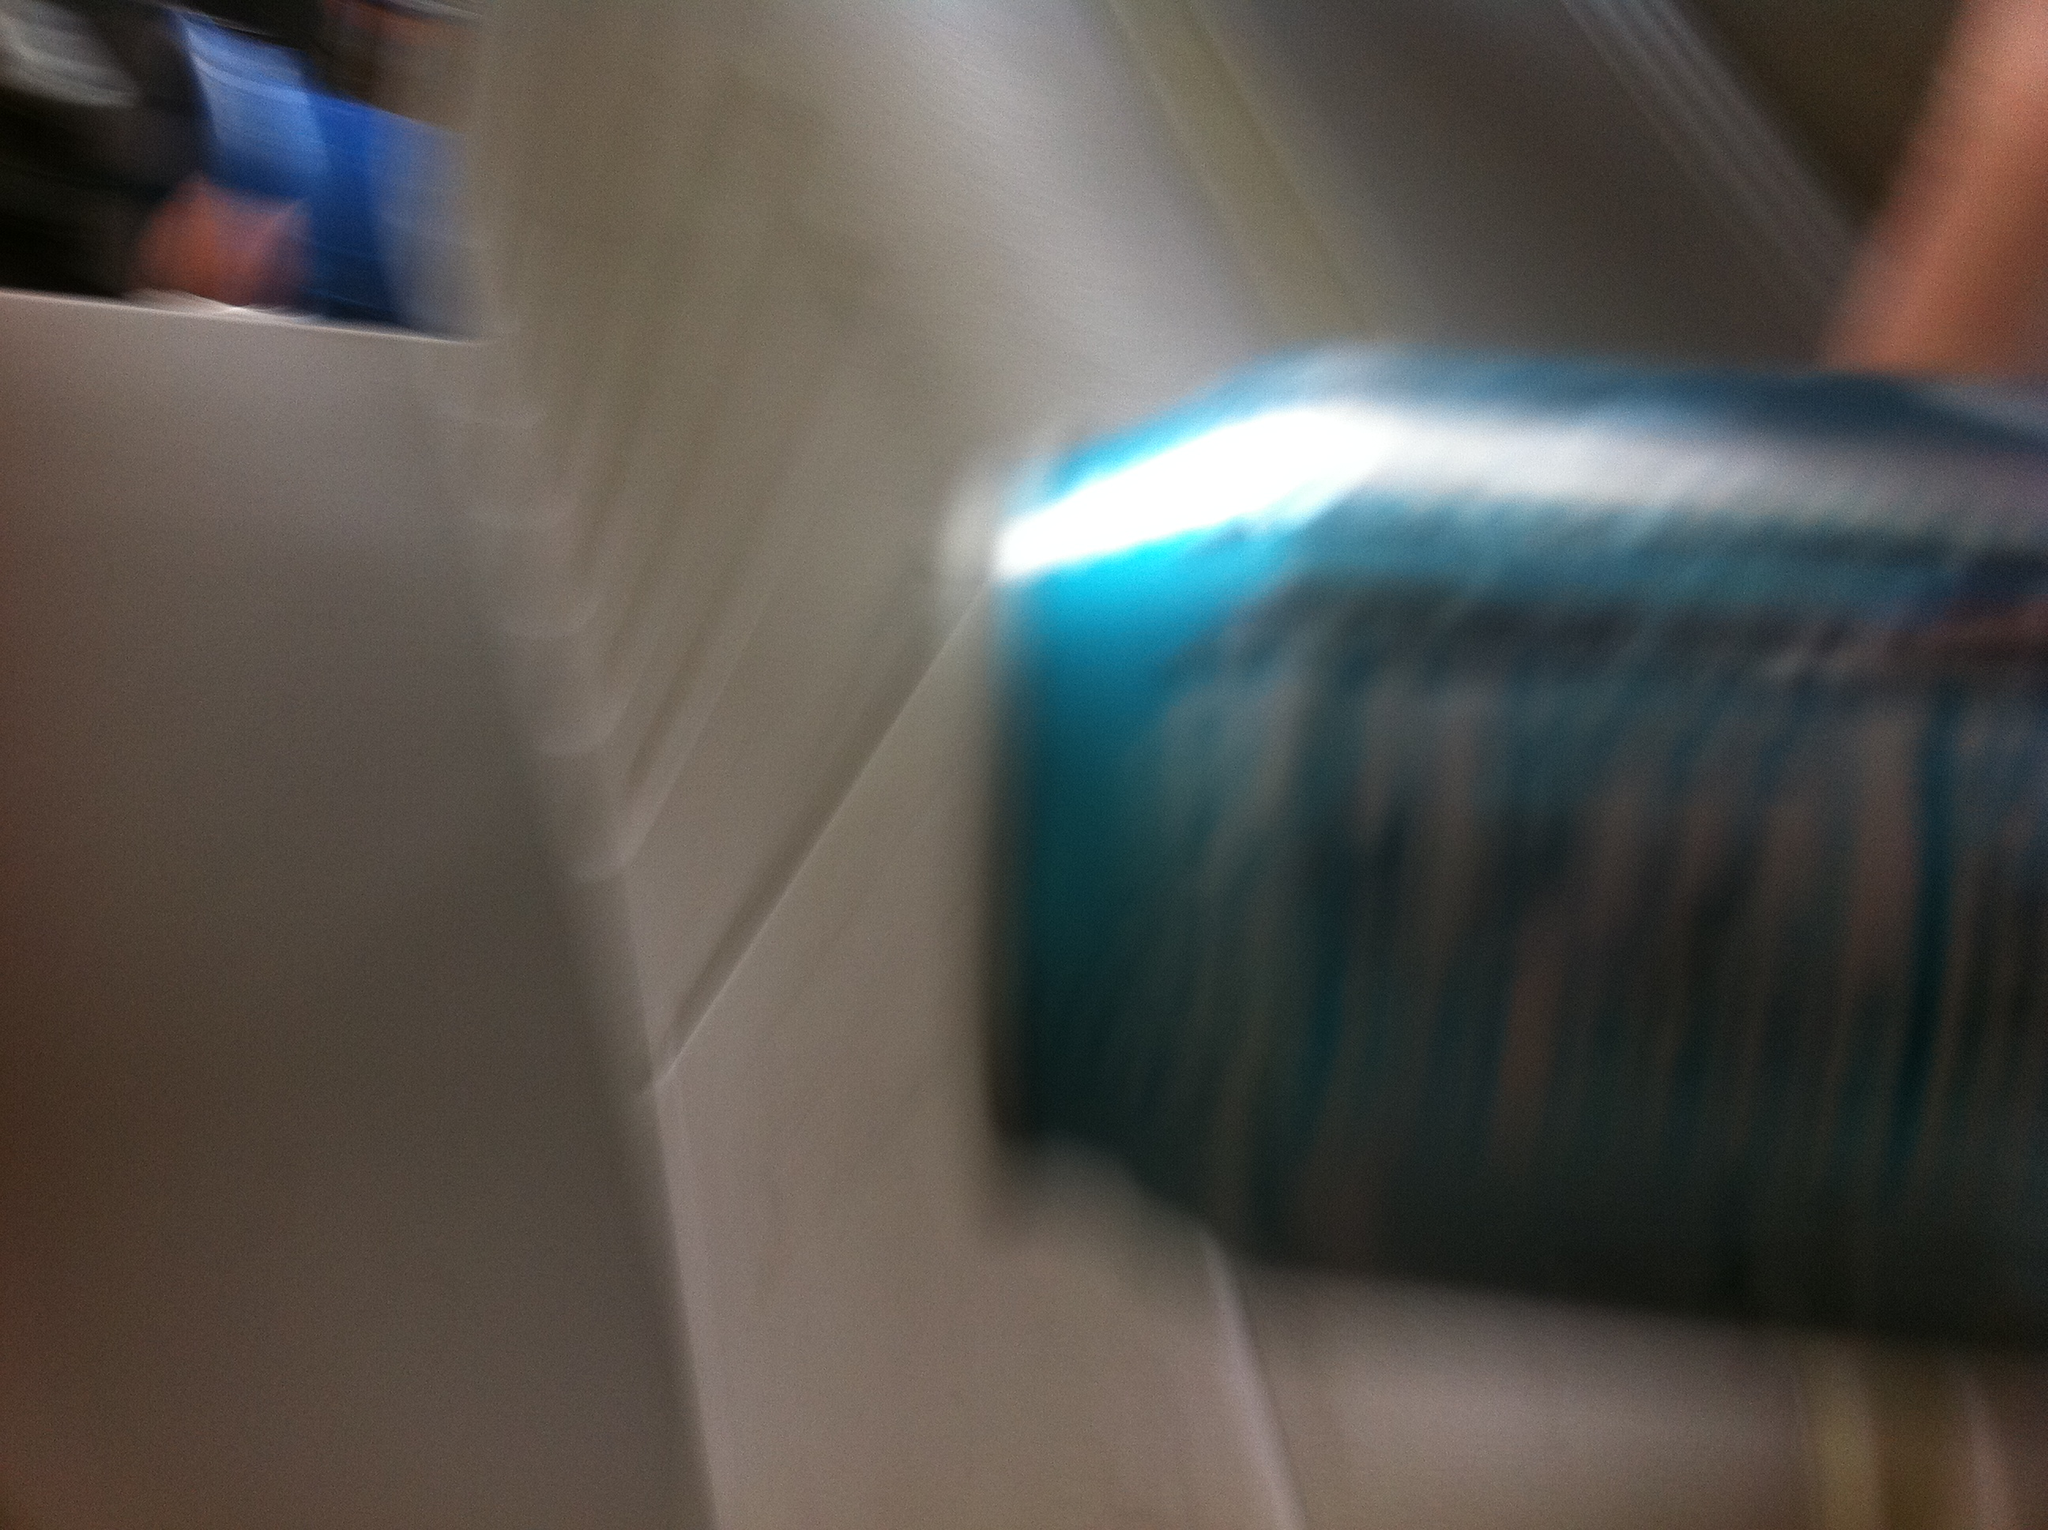Can you describe this soda can? The image shows a blurry soda can that seems to have a blue dominant color. There are streaks or patterns, potentially with white or lighter shades. Unfortunately, due to the blurriness, any specific branding or labeling is not discernible. What could be the possible brand of the soda? Based on the blue color theme, some common soda brands that use blue in their designs include Pepsi, Mountain Dew Voltage, and certain energy drinks like Monster Energy Ultra Blue. However, due to the lack of clear details, this remains speculative. Imagine a story where this soda can played a significant role in an adventure. In a distant future, when Earth was overrun by lush, unforgiving jungles, a group of explorers ventured out to find remnants of the old world. Deep in the heart of an abandoned city, cloaked in vines and foliage, they discovered a shimmering, blue soda can. To their surprise, it wasn’t just an ordinary drink – it contained an advanced, rejuvenating elixir developed before the great fall. This soda became the key to unlocking ancient memories and restoring the lost knowledge of mankind. The explorers, bound by their discovery, embarked on a mission to find more cans, deciphering clues hidden in ancient ruins, leading to a new age of enlightenment. 